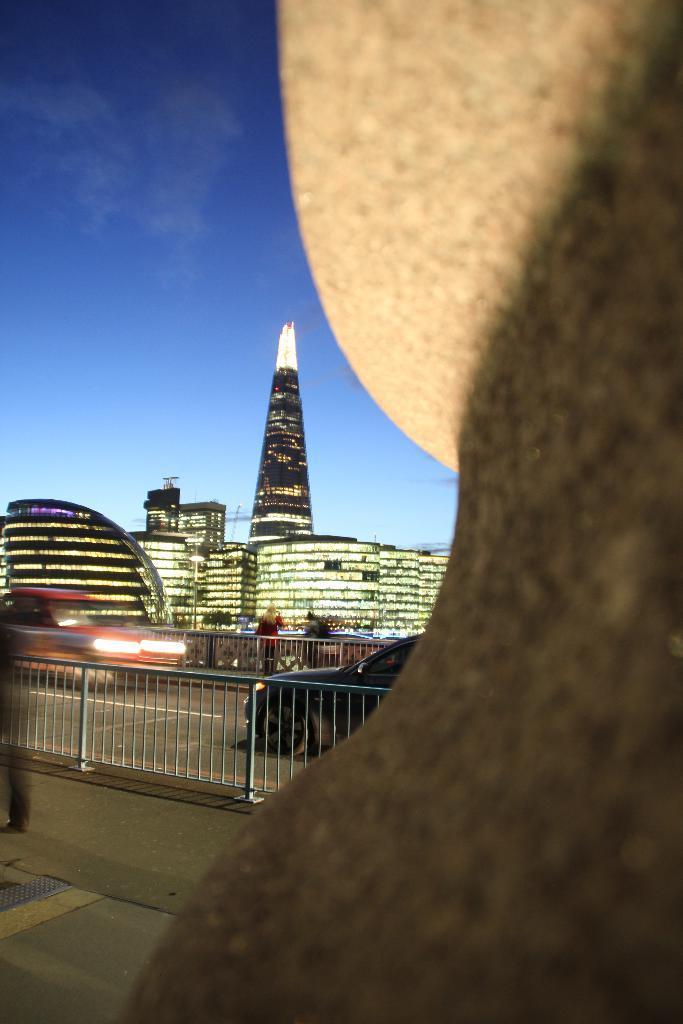Can you describe this image briefly? This image consists of buildings and skyscrapers. At the bottom, there is a road. In the middle, we can see a fencing along with a car. At the top, there is sky. On the right, it looks like a wall or a tree. 